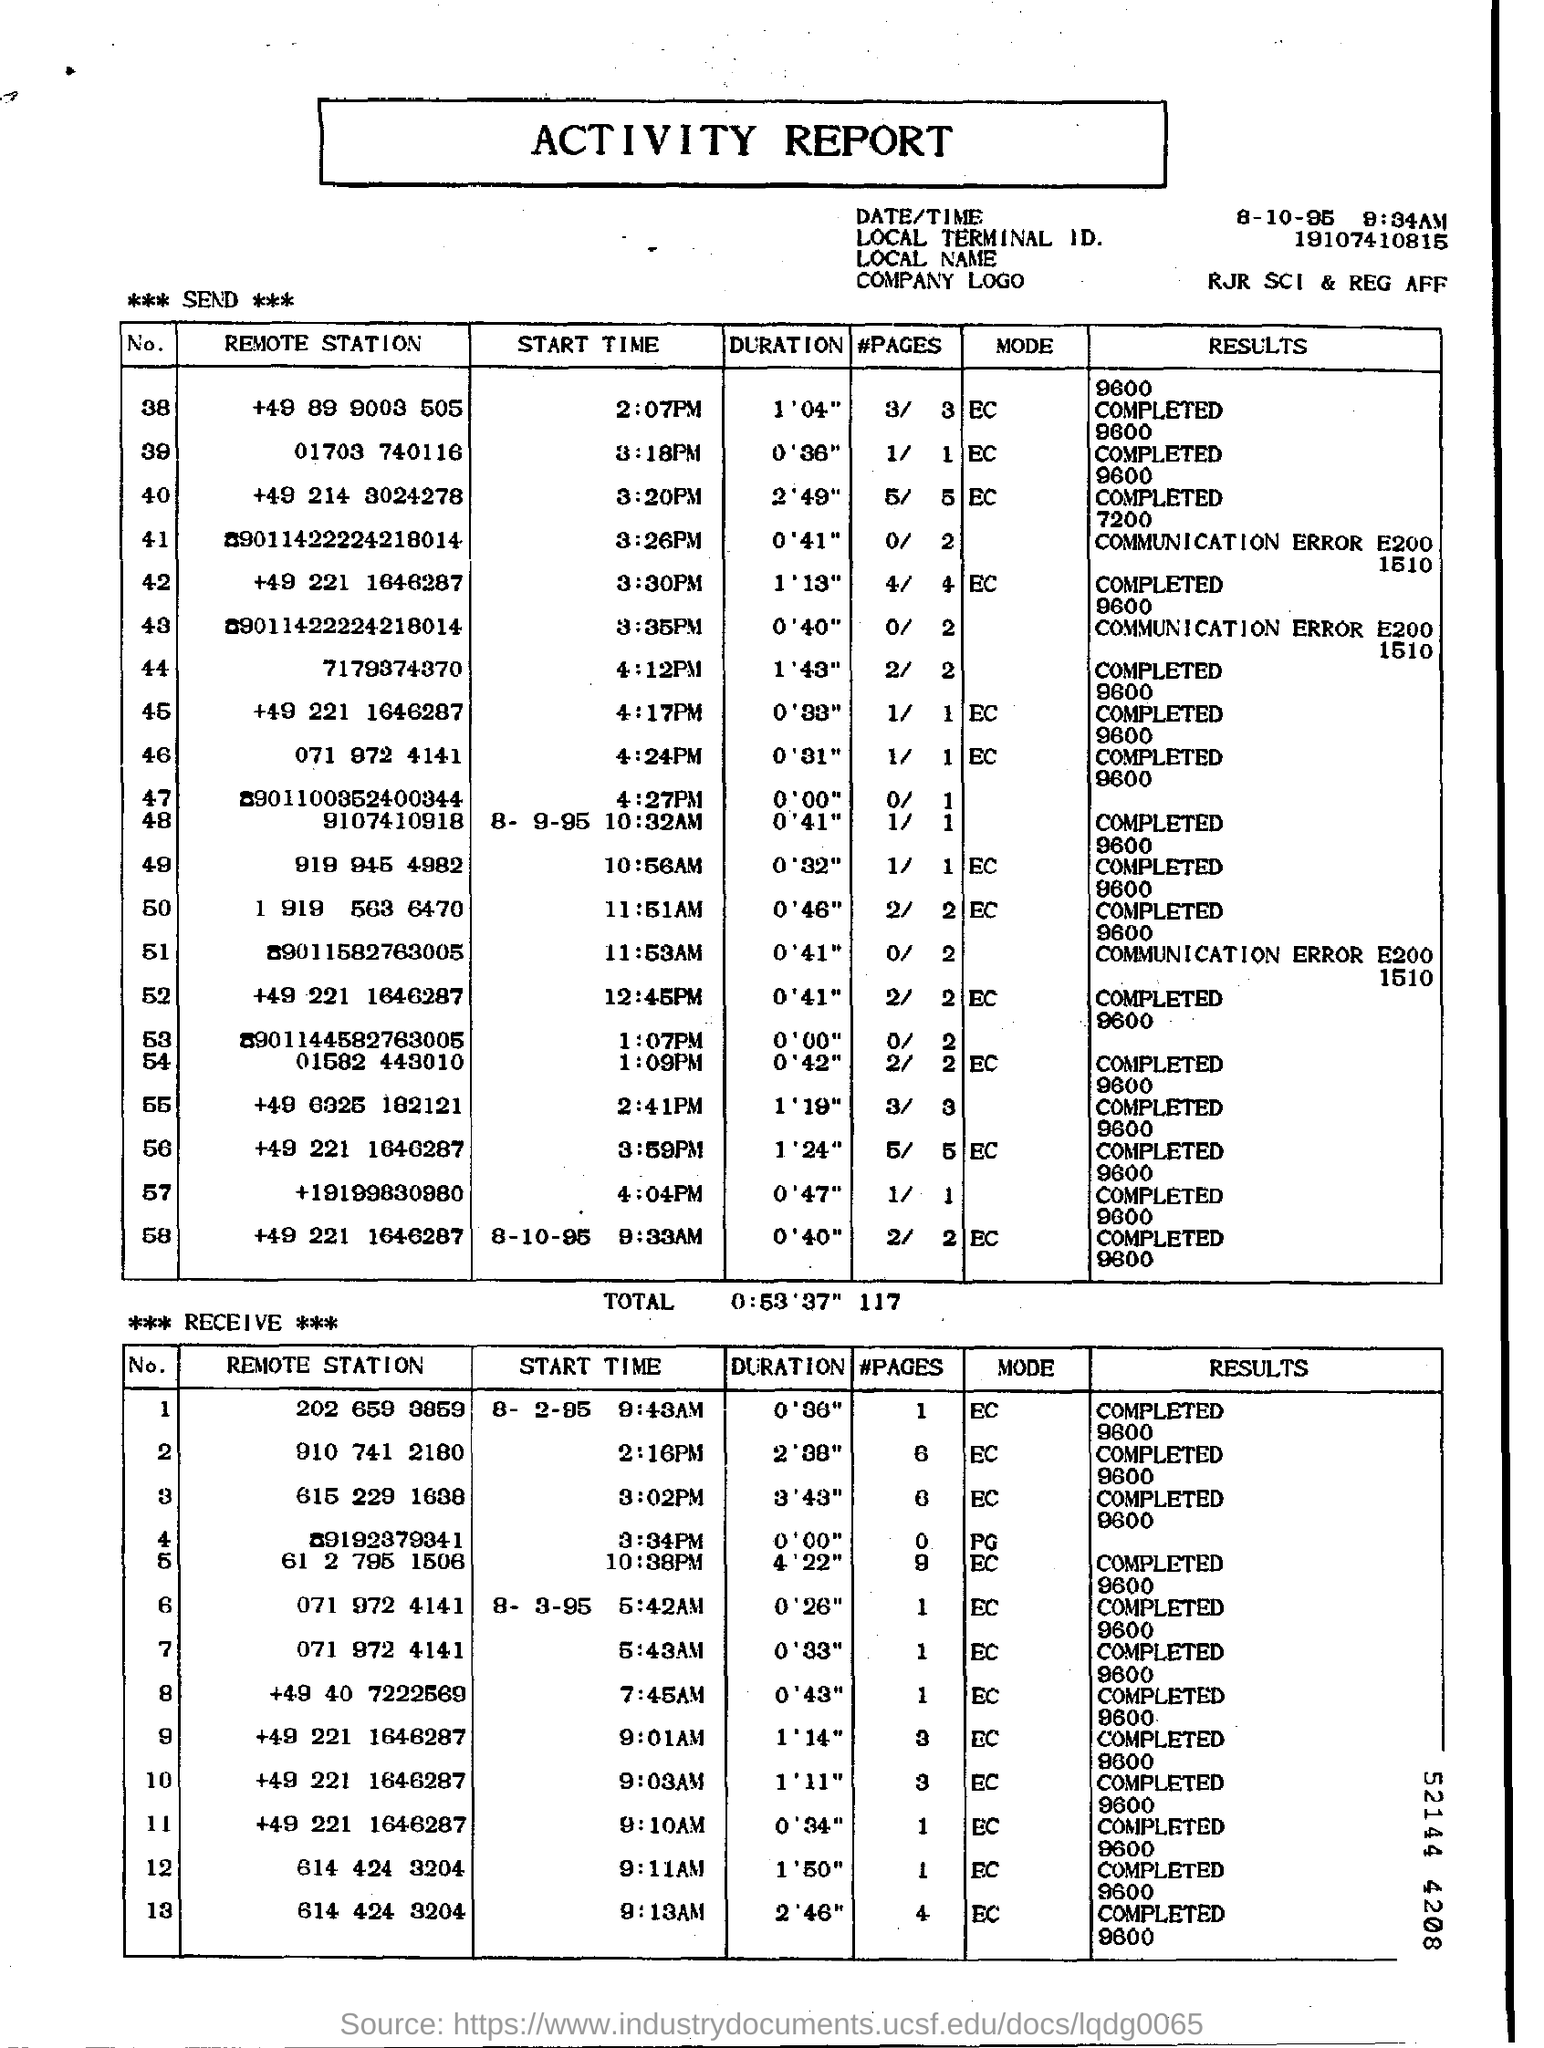Which Report is this
Offer a terse response. Activity Report. What is the COMPANY LOGO given in this report
Your response must be concise. RJR SCI & REG AFF. 